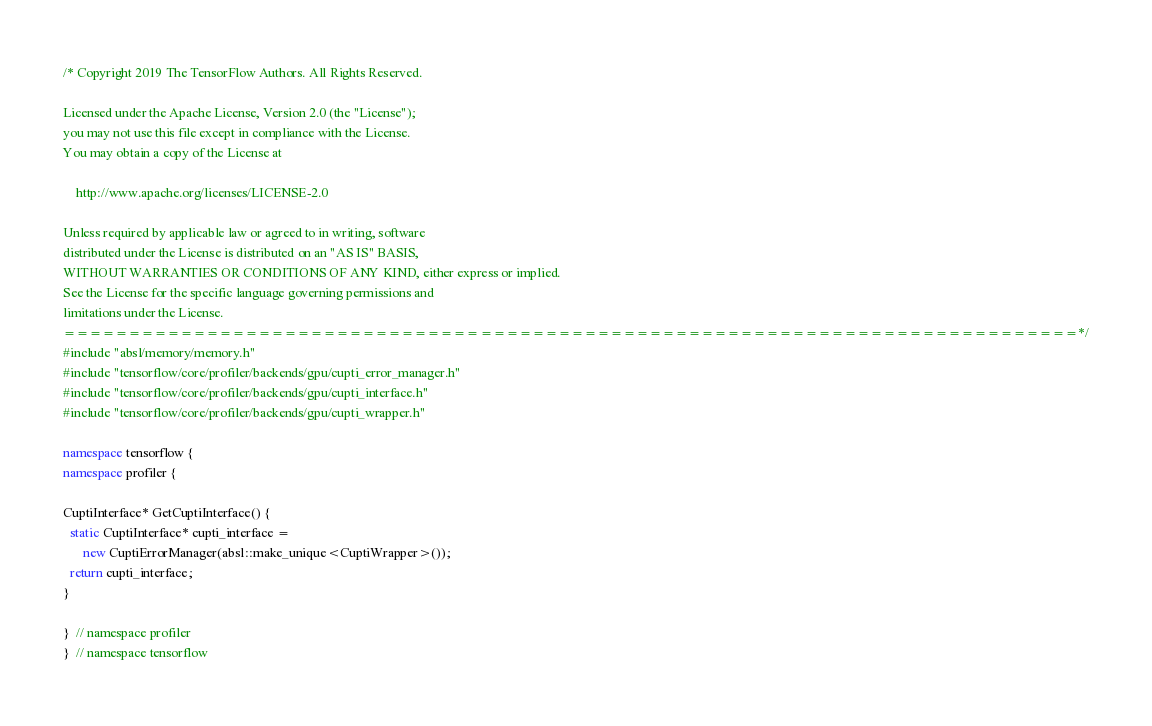Convert code to text. <code><loc_0><loc_0><loc_500><loc_500><_C++_>/* Copyright 2019 The TensorFlow Authors. All Rights Reserved.

Licensed under the Apache License, Version 2.0 (the "License");
you may not use this file except in compliance with the License.
You may obtain a copy of the License at

    http://www.apache.org/licenses/LICENSE-2.0

Unless required by applicable law or agreed to in writing, software
distributed under the License is distributed on an "AS IS" BASIS,
WITHOUT WARRANTIES OR CONDITIONS OF ANY KIND, either express or implied.
See the License for the specific language governing permissions and
limitations under the License.
==============================================================================*/
#include "absl/memory/memory.h"
#include "tensorflow/core/profiler/backends/gpu/cupti_error_manager.h"
#include "tensorflow/core/profiler/backends/gpu/cupti_interface.h"
#include "tensorflow/core/profiler/backends/gpu/cupti_wrapper.h"

namespace tensorflow {
namespace profiler {

CuptiInterface* GetCuptiInterface() {
  static CuptiInterface* cupti_interface =
      new CuptiErrorManager(absl::make_unique<CuptiWrapper>());
  return cupti_interface;
}

}  // namespace profiler
}  // namespace tensorflow
</code> 